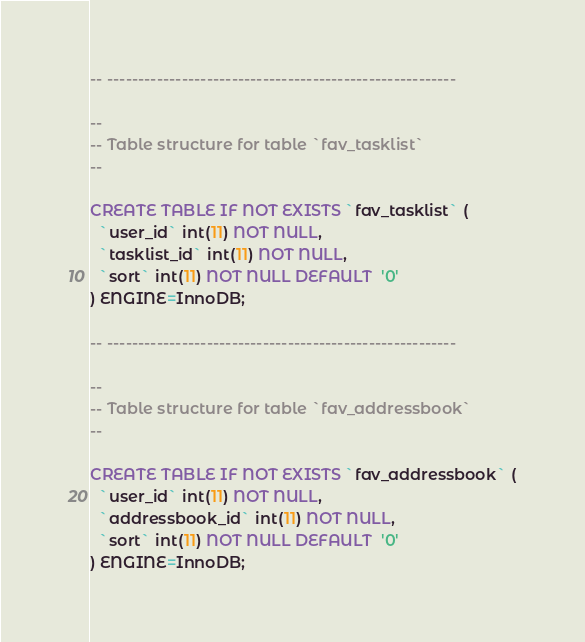Convert code to text. <code><loc_0><loc_0><loc_500><loc_500><_SQL_>
-- --------------------------------------------------------

--
-- Table structure for table `fav_tasklist`
--

CREATE TABLE IF NOT EXISTS `fav_tasklist` (
  `user_id` int(11) NOT NULL,
  `tasklist_id` int(11) NOT NULL,
  `sort` int(11) NOT NULL DEFAULT  '0'
) ENGINE=InnoDB;

-- --------------------------------------------------------

--
-- Table structure for table `fav_addressbook`
--

CREATE TABLE IF NOT EXISTS `fav_addressbook` (
  `user_id` int(11) NOT NULL,
  `addressbook_id` int(11) NOT NULL,
  `sort` int(11) NOT NULL DEFAULT  '0'
) ENGINE=InnoDB;</code> 